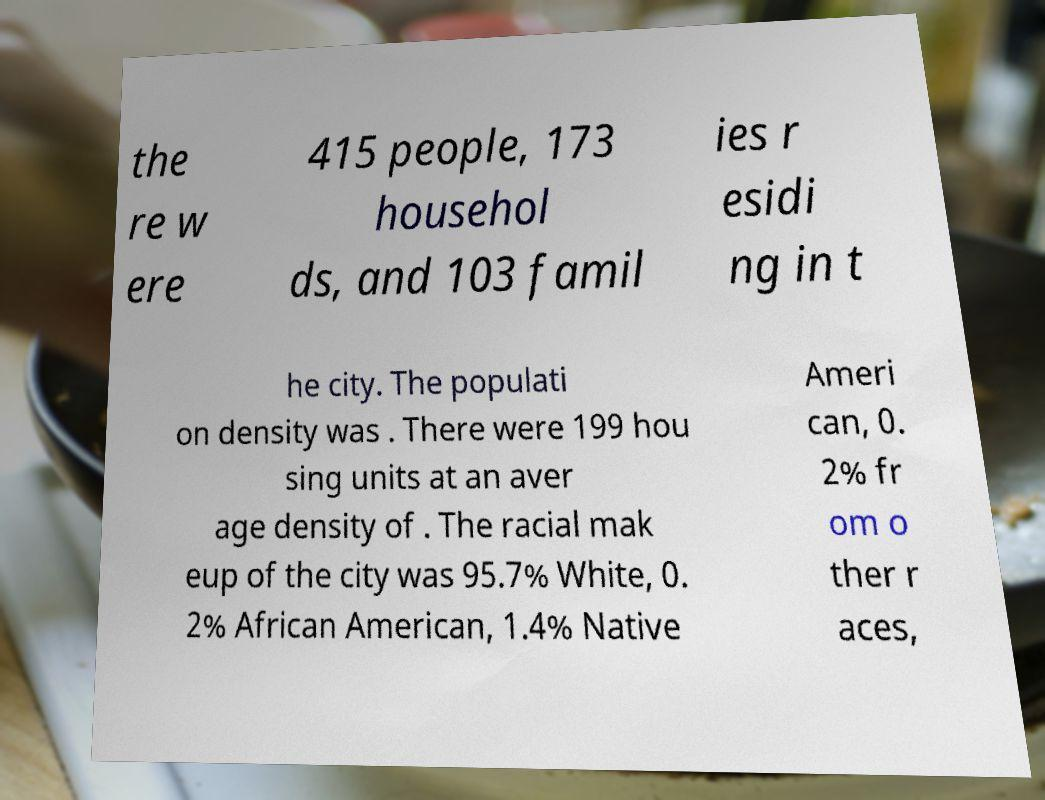Please read and relay the text visible in this image. What does it say? the re w ere 415 people, 173 househol ds, and 103 famil ies r esidi ng in t he city. The populati on density was . There were 199 hou sing units at an aver age density of . The racial mak eup of the city was 95.7% White, 0. 2% African American, 1.4% Native Ameri can, 0. 2% fr om o ther r aces, 